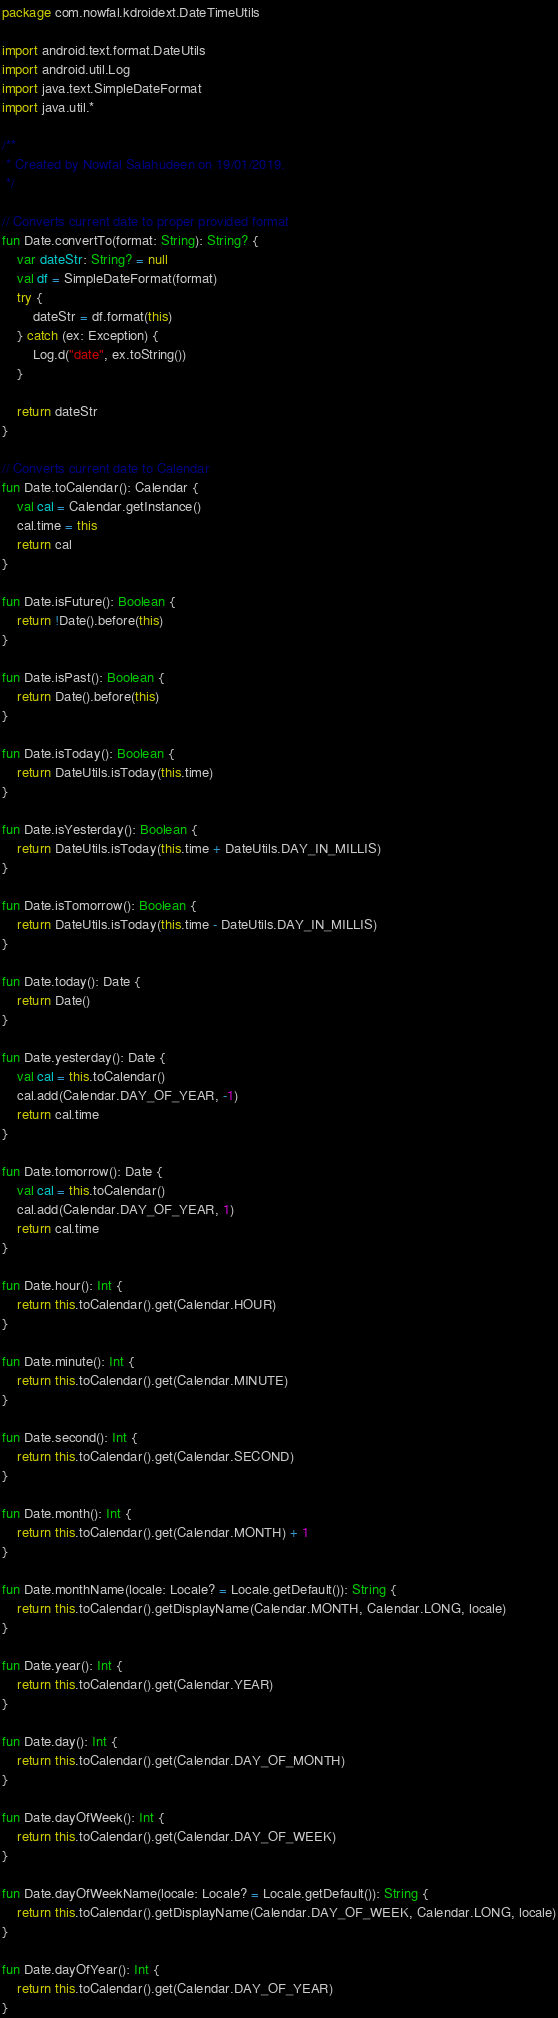<code> <loc_0><loc_0><loc_500><loc_500><_Kotlin_>package com.nowfal.kdroidext.DateTimeUtils

import android.text.format.DateUtils
import android.util.Log
import java.text.SimpleDateFormat
import java.util.*

/**
 * Created by Nowfal Salahudeen on 19/01/2019.
 */

// Converts current date to proper provided format
fun Date.convertTo(format: String): String? {
    var dateStr: String? = null
    val df = SimpleDateFormat(format)
    try {
        dateStr = df.format(this)
    } catch (ex: Exception) {
        Log.d("date", ex.toString())
    }

    return dateStr
}

// Converts current date to Calendar
fun Date.toCalendar(): Calendar {
    val cal = Calendar.getInstance()
    cal.time = this
    return cal
}

fun Date.isFuture(): Boolean {
    return !Date().before(this)
}

fun Date.isPast(): Boolean {
    return Date().before(this)
}

fun Date.isToday(): Boolean {
    return DateUtils.isToday(this.time)
}

fun Date.isYesterday(): Boolean {
    return DateUtils.isToday(this.time + DateUtils.DAY_IN_MILLIS)
}

fun Date.isTomorrow(): Boolean {
    return DateUtils.isToday(this.time - DateUtils.DAY_IN_MILLIS)
}

fun Date.today(): Date {
    return Date()
}

fun Date.yesterday(): Date {
    val cal = this.toCalendar()
    cal.add(Calendar.DAY_OF_YEAR, -1)
    return cal.time
}

fun Date.tomorrow(): Date {
    val cal = this.toCalendar()
    cal.add(Calendar.DAY_OF_YEAR, 1)
    return cal.time
}

fun Date.hour(): Int {
    return this.toCalendar().get(Calendar.HOUR)
}

fun Date.minute(): Int {
    return this.toCalendar().get(Calendar.MINUTE)
}

fun Date.second(): Int {
    return this.toCalendar().get(Calendar.SECOND)
}

fun Date.month(): Int {
    return this.toCalendar().get(Calendar.MONTH) + 1
}

fun Date.monthName(locale: Locale? = Locale.getDefault()): String {
    return this.toCalendar().getDisplayName(Calendar.MONTH, Calendar.LONG, locale)
}

fun Date.year(): Int {
    return this.toCalendar().get(Calendar.YEAR)
}

fun Date.day(): Int {
    return this.toCalendar().get(Calendar.DAY_OF_MONTH)
}

fun Date.dayOfWeek(): Int {
    return this.toCalendar().get(Calendar.DAY_OF_WEEK)
}

fun Date.dayOfWeekName(locale: Locale? = Locale.getDefault()): String {
    return this.toCalendar().getDisplayName(Calendar.DAY_OF_WEEK, Calendar.LONG, locale)
}

fun Date.dayOfYear(): Int {
    return this.toCalendar().get(Calendar.DAY_OF_YEAR)
}</code> 